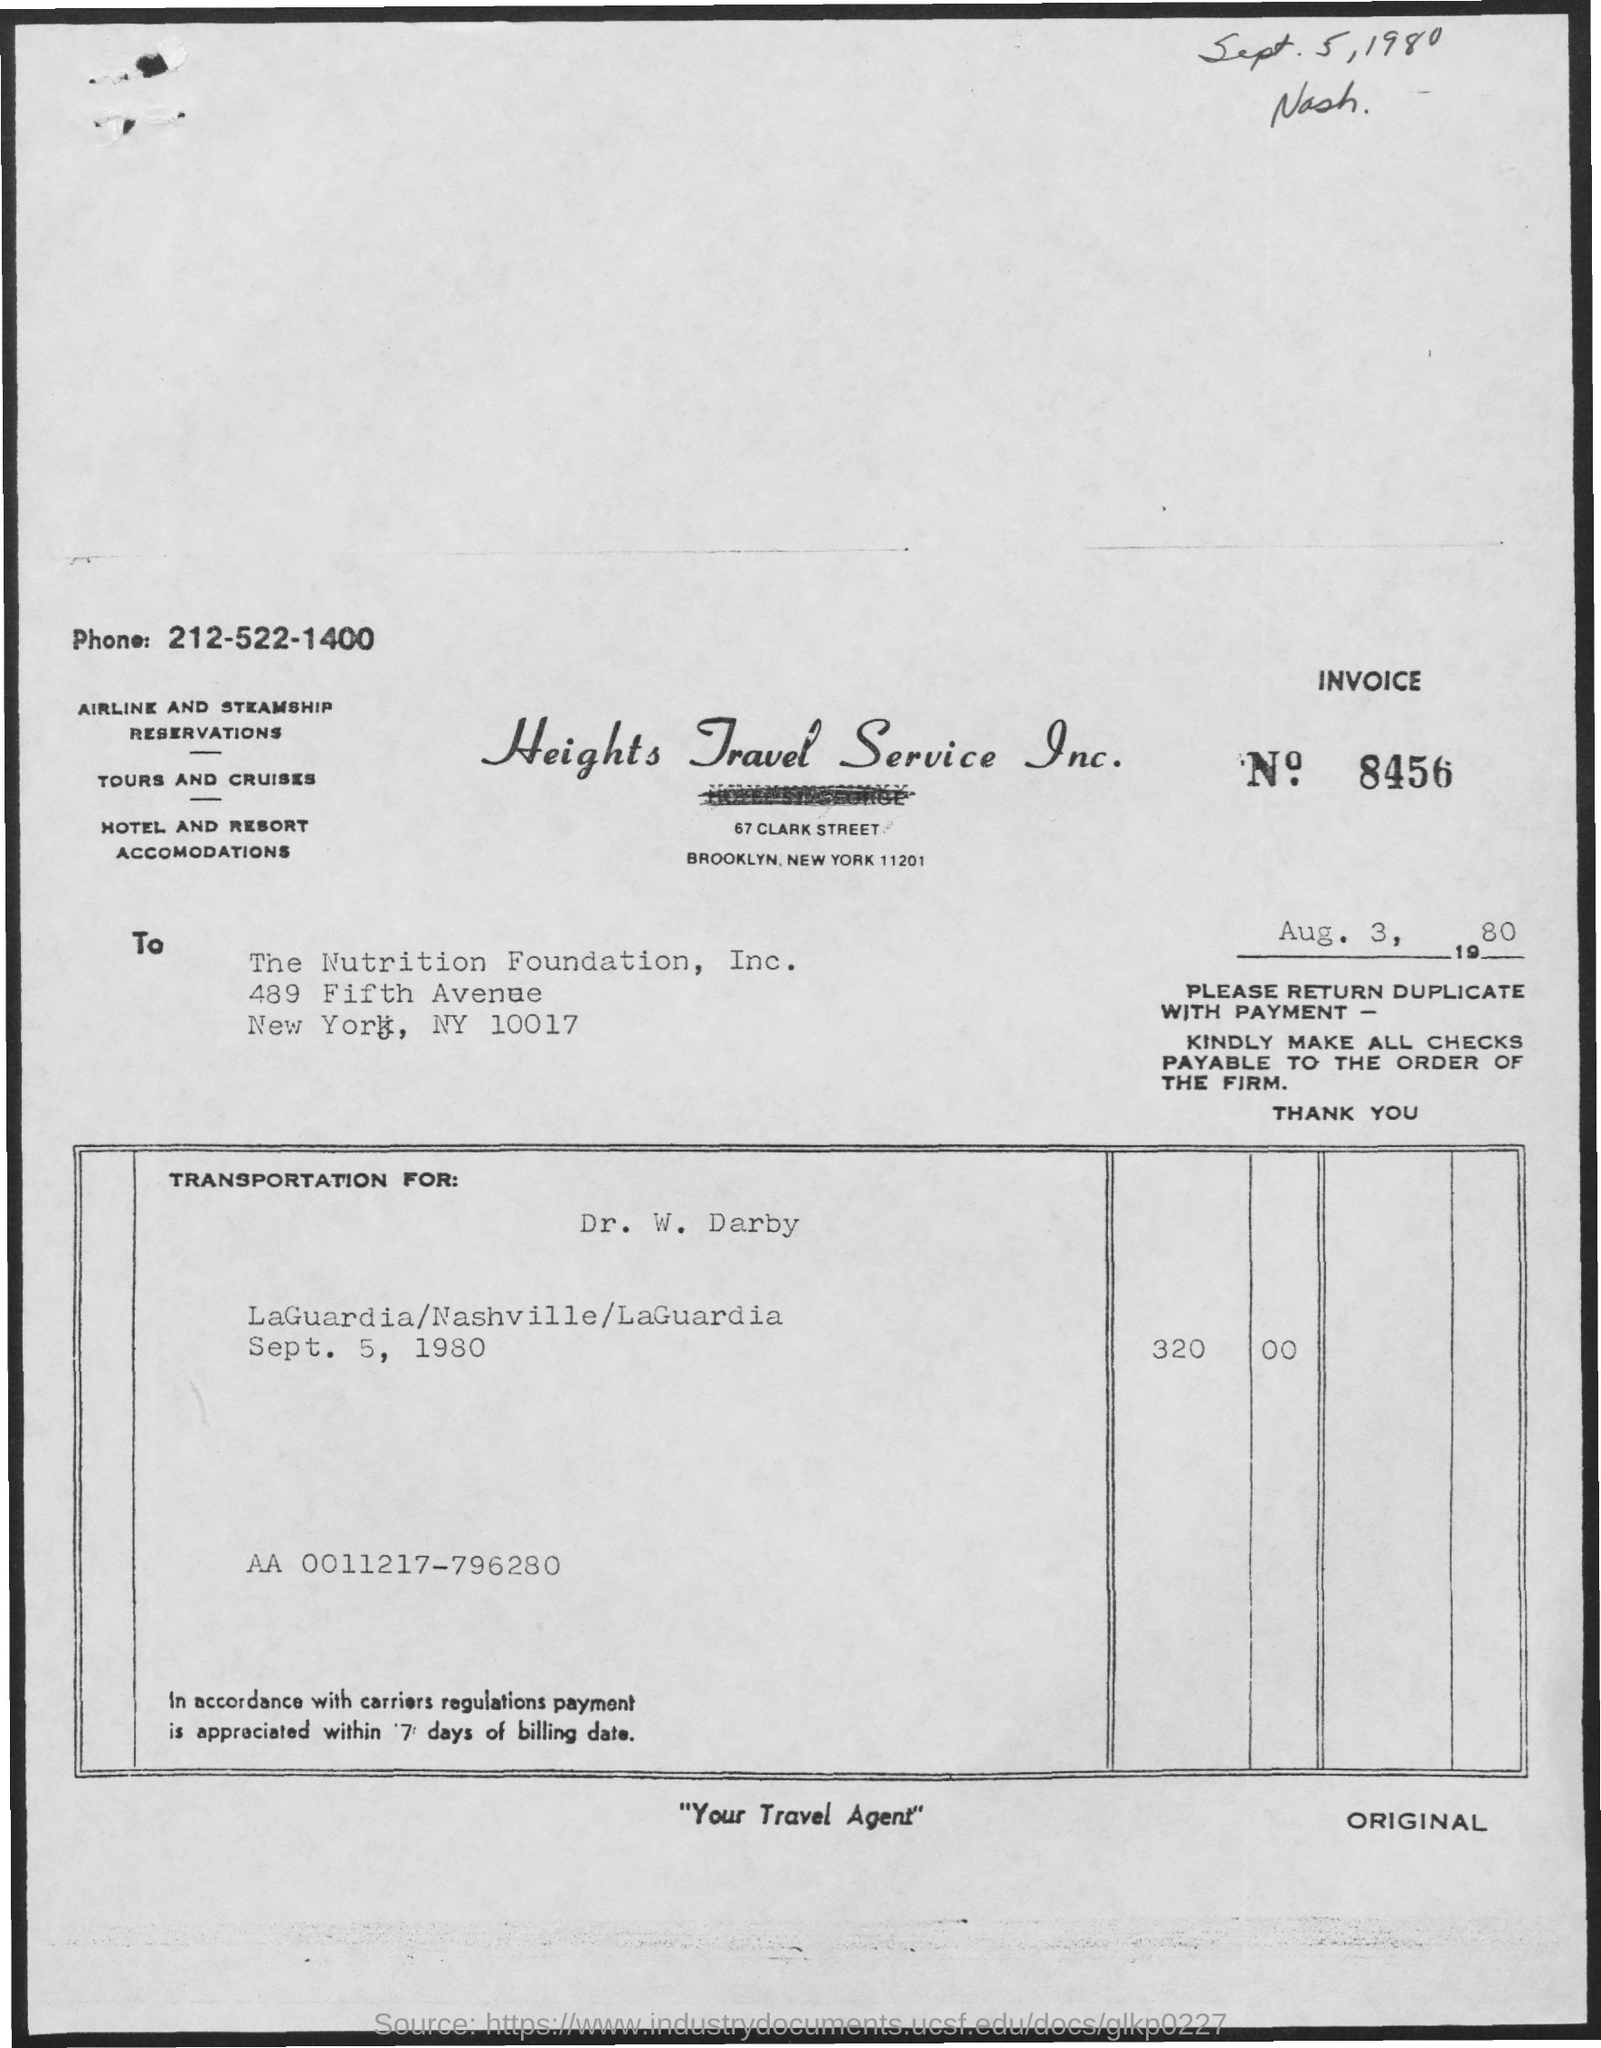Identify some key points in this picture. The phone number given is 212-522-1400. The transportation is for Dr. W. Darby. The phrase 'Your Travel Agent' is written at the middle bottom of the page. The code written inside the box is "aa 0011217-796280..". What is the invoice number? 